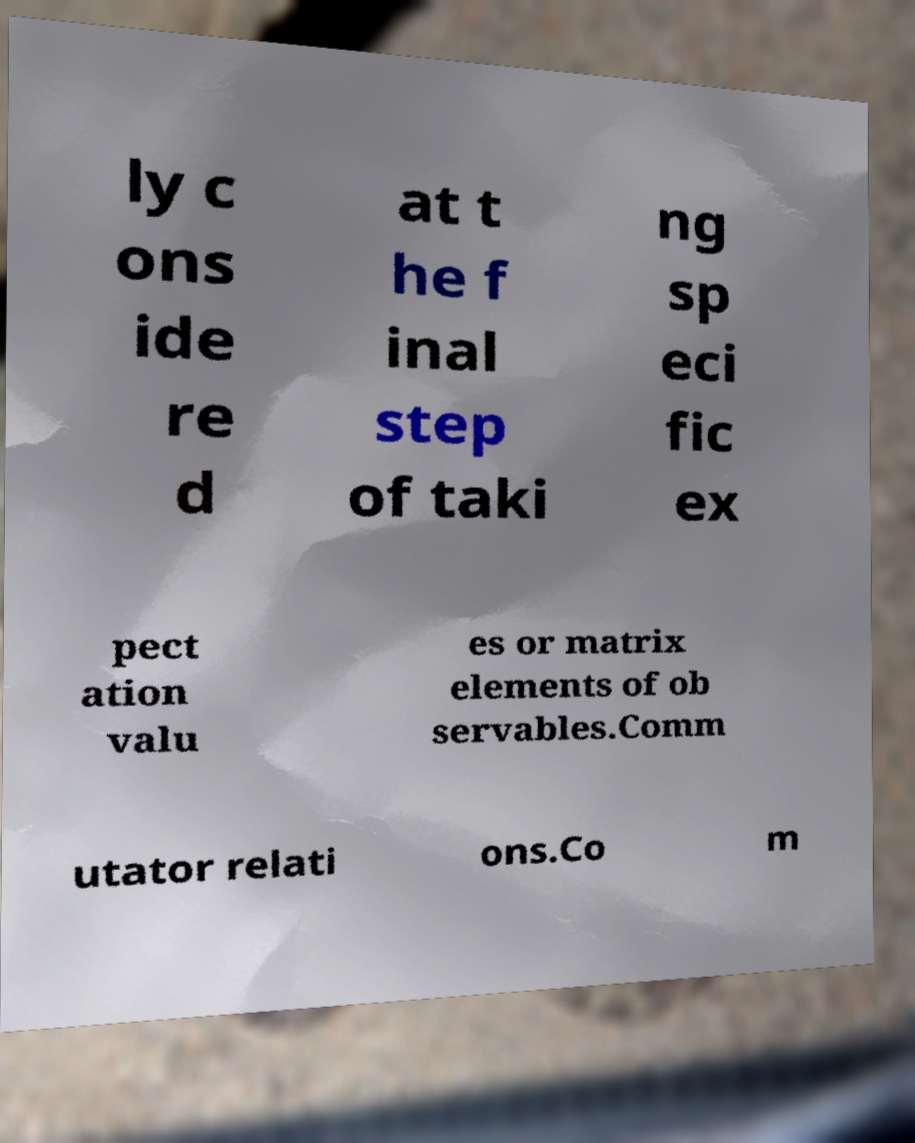Please identify and transcribe the text found in this image. ly c ons ide re d at t he f inal step of taki ng sp eci fic ex pect ation valu es or matrix elements of ob servables.Comm utator relati ons.Co m 